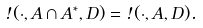<formula> <loc_0><loc_0><loc_500><loc_500>\omega ( \cdot , A \cap A ^ { \ast } , D ) = \omega ( \cdot , A , D ) .</formula> 